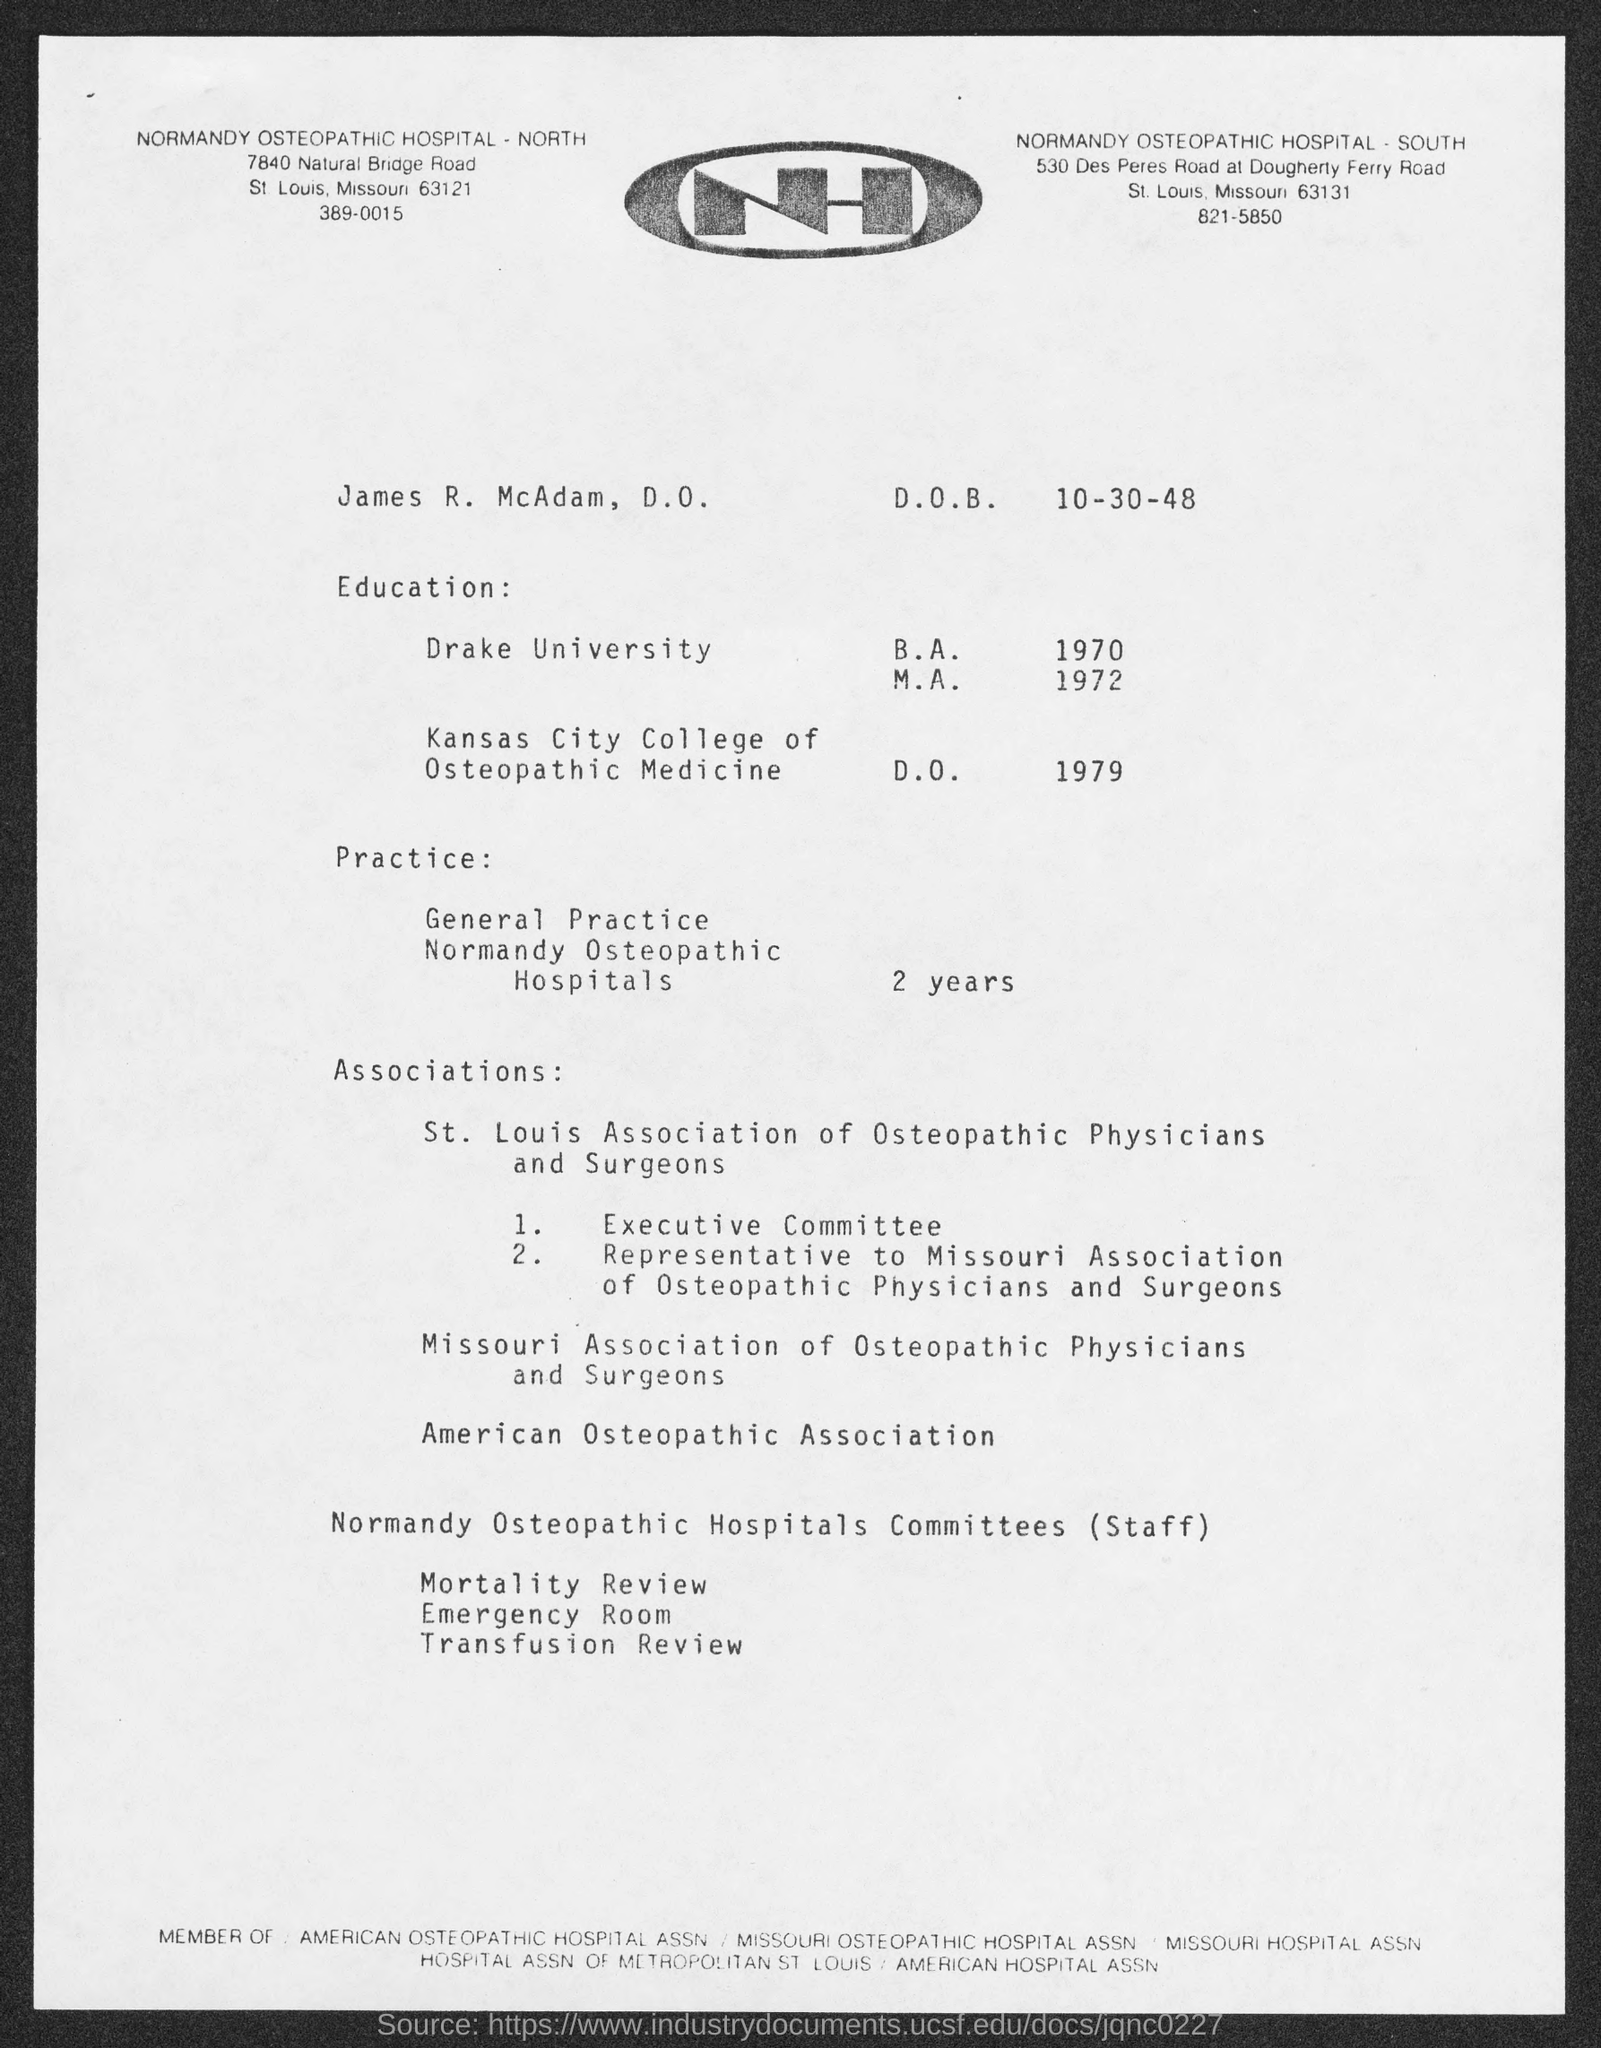List a handful of essential elements in this visual. James received his B.A. from Drake University. The telephone number of Normandy Osteopathic Hospital-North is 389-0015. What is the date of birth for James, who was born on October 30, 1948? James worked as a general practitioner at Normandy Osteopathic Hospitals for a period of two years. The name of the individual is James R. McAdam, D.O. 